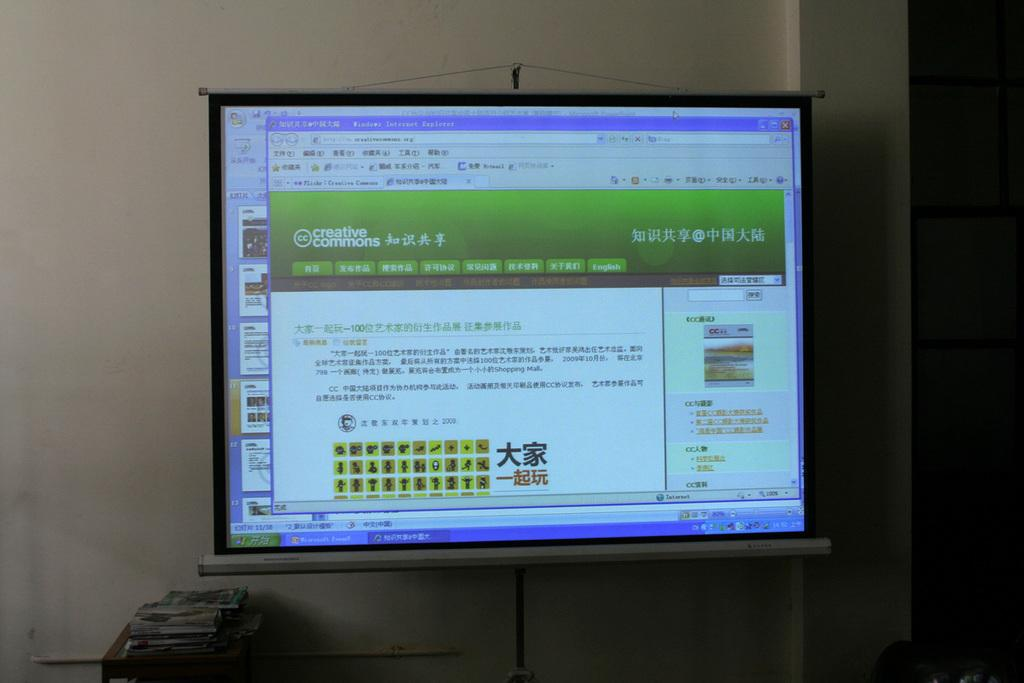<image>
Create a compact narrative representing the image presented. A computer monitor with a screen opened up to creative commons at the top and the rest of the page in Chinese. 